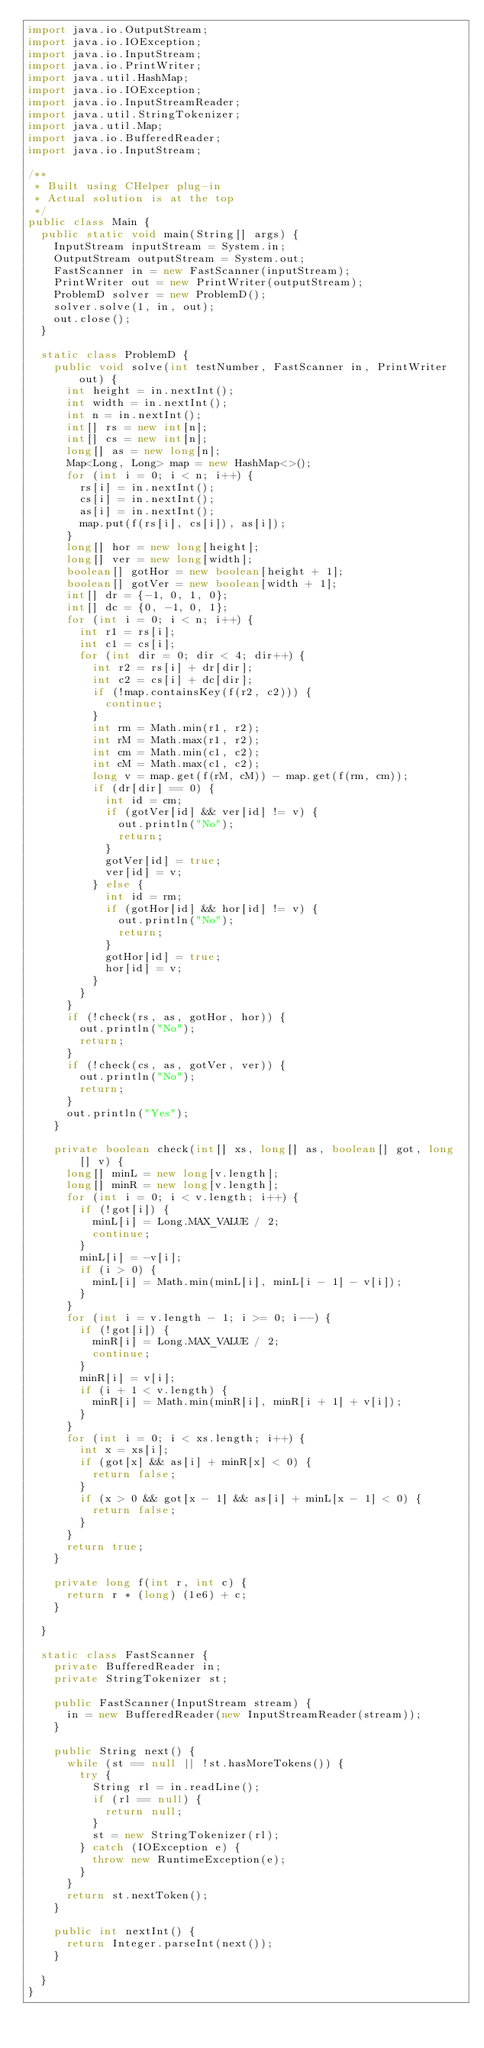<code> <loc_0><loc_0><loc_500><loc_500><_Java_>import java.io.OutputStream;
import java.io.IOException;
import java.io.InputStream;
import java.io.PrintWriter;
import java.util.HashMap;
import java.io.IOException;
import java.io.InputStreamReader;
import java.util.StringTokenizer;
import java.util.Map;
import java.io.BufferedReader;
import java.io.InputStream;

/**
 * Built using CHelper plug-in
 * Actual solution is at the top
 */
public class Main {
	public static void main(String[] args) {
		InputStream inputStream = System.in;
		OutputStream outputStream = System.out;
		FastScanner in = new FastScanner(inputStream);
		PrintWriter out = new PrintWriter(outputStream);
		ProblemD solver = new ProblemD();
		solver.solve(1, in, out);
		out.close();
	}

	static class ProblemD {
		public void solve(int testNumber, FastScanner in, PrintWriter out) {
			int height = in.nextInt();
			int width = in.nextInt();
			int n = in.nextInt();
			int[] rs = new int[n];
			int[] cs = new int[n];
			long[] as = new long[n];
			Map<Long, Long> map = new HashMap<>();
			for (int i = 0; i < n; i++) {
				rs[i] = in.nextInt();
				cs[i] = in.nextInt();
				as[i] = in.nextInt();
				map.put(f(rs[i], cs[i]), as[i]);
			}
			long[] hor = new long[height];
			long[] ver = new long[width];
			boolean[] gotHor = new boolean[height + 1];
			boolean[] gotVer = new boolean[width + 1];
			int[] dr = {-1, 0, 1, 0};
			int[] dc = {0, -1, 0, 1};
			for (int i = 0; i < n; i++) {
				int r1 = rs[i];
				int c1 = cs[i];
				for (int dir = 0; dir < 4; dir++) {
					int r2 = rs[i] + dr[dir];
					int c2 = cs[i] + dc[dir];
					if (!map.containsKey(f(r2, c2))) {
						continue;
					}
					int rm = Math.min(r1, r2);
					int rM = Math.max(r1, r2);
					int cm = Math.min(c1, c2);
					int cM = Math.max(c1, c2);
					long v = map.get(f(rM, cM)) - map.get(f(rm, cm));
					if (dr[dir] == 0) {
						int id = cm;
						if (gotVer[id] && ver[id] != v) {
							out.println("No");
							return;
						}
						gotVer[id] = true;
						ver[id] = v;
					} else {
						int id = rm;
						if (gotHor[id] && hor[id] != v) {
							out.println("No");
							return;
						}
						gotHor[id] = true;
						hor[id] = v;
					}
				}
			}
			if (!check(rs, as, gotHor, hor)) {
				out.println("No");
				return;
			}
			if (!check(cs, as, gotVer, ver)) {
				out.println("No");
				return;
			}
			out.println("Yes");
		}

		private boolean check(int[] xs, long[] as, boolean[] got, long[] v) {
			long[] minL = new long[v.length];
			long[] minR = new long[v.length];
			for (int i = 0; i < v.length; i++) {
				if (!got[i]) {
					minL[i] = Long.MAX_VALUE / 2;
					continue;
				}
				minL[i] = -v[i];
				if (i > 0) {
					minL[i] = Math.min(minL[i], minL[i - 1] - v[i]);
				}
			}
			for (int i = v.length - 1; i >= 0; i--) {
				if (!got[i]) {
					minR[i] = Long.MAX_VALUE / 2;
					continue;
				}
				minR[i] = v[i];
				if (i + 1 < v.length) {
					minR[i] = Math.min(minR[i], minR[i + 1] + v[i]);
				}
			}
			for (int i = 0; i < xs.length; i++) {
				int x = xs[i];
				if (got[x] && as[i] + minR[x] < 0) {
					return false;
				}
				if (x > 0 && got[x - 1] && as[i] + minL[x - 1] < 0) {
					return false;
				}
			}
			return true;
		}

		private long f(int r, int c) {
			return r * (long) (1e6) + c;
		}

	}

	static class FastScanner {
		private BufferedReader in;
		private StringTokenizer st;

		public FastScanner(InputStream stream) {
			in = new BufferedReader(new InputStreamReader(stream));
		}

		public String next() {
			while (st == null || !st.hasMoreTokens()) {
				try {
					String rl = in.readLine();
					if (rl == null) {
						return null;
					}
					st = new StringTokenizer(rl);
				} catch (IOException e) {
					throw new RuntimeException(e);
				}
			}
			return st.nextToken();
		}

		public int nextInt() {
			return Integer.parseInt(next());
		}

	}
}

</code> 